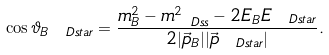<formula> <loc_0><loc_0><loc_500><loc_500>\cos \vartheta _ { B \ D s t a r } = \frac { m ^ { 2 } _ { B } - m ^ { 2 } _ { \ D s s } - 2 E _ { B } E _ { \ D s t a r } } { 2 | \vec { p } _ { B } | | \vec { p } _ { \ D s t a r } | } .</formula> 